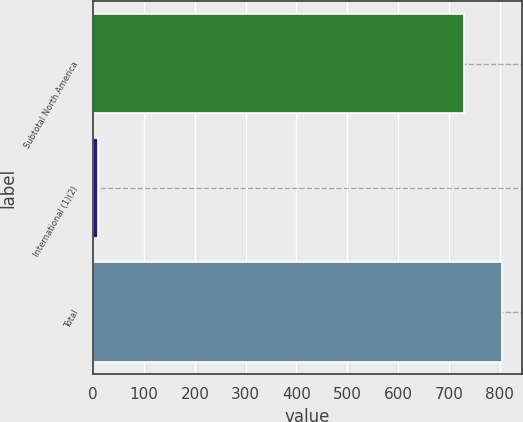<chart> <loc_0><loc_0><loc_500><loc_500><bar_chart><fcel>Subtotal North America<fcel>International (1)(2)<fcel>Total<nl><fcel>731<fcel>10<fcel>804.1<nl></chart> 